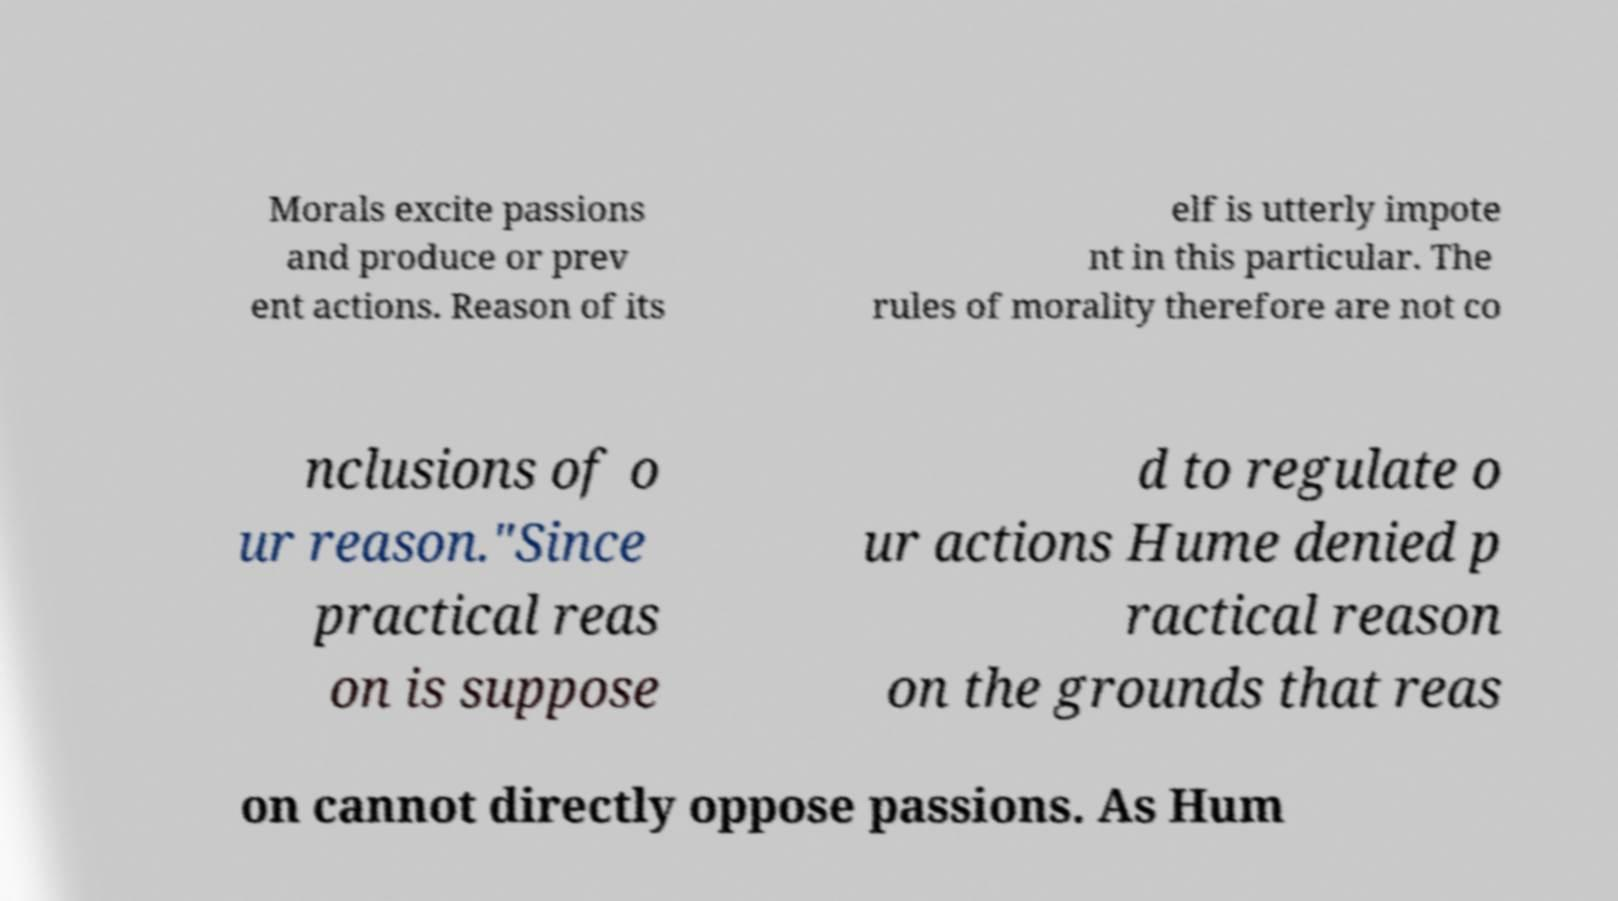There's text embedded in this image that I need extracted. Can you transcribe it verbatim? Morals excite passions and produce or prev ent actions. Reason of its elf is utterly impote nt in this particular. The rules of morality therefore are not co nclusions of o ur reason."Since practical reas on is suppose d to regulate o ur actions Hume denied p ractical reason on the grounds that reas on cannot directly oppose passions. As Hum 